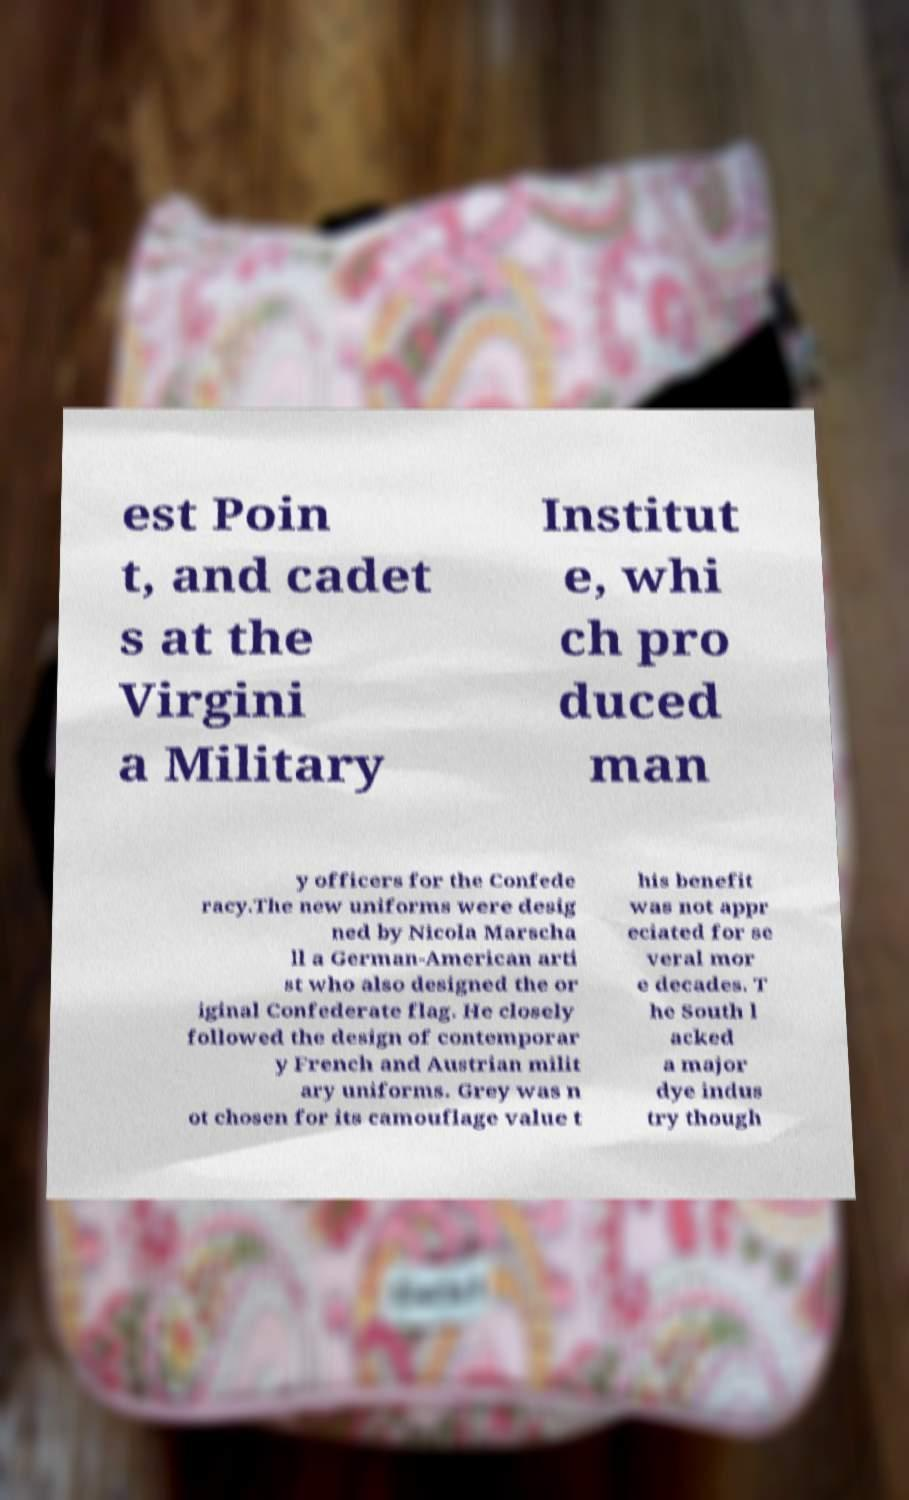Could you extract and type out the text from this image? est Poin t, and cadet s at the Virgini a Military Institut e, whi ch pro duced man y officers for the Confede racy.The new uniforms were desig ned by Nicola Marscha ll a German-American arti st who also designed the or iginal Confederate flag. He closely followed the design of contemporar y French and Austrian milit ary uniforms. Grey was n ot chosen for its camouflage value t his benefit was not appr eciated for se veral mor e decades. T he South l acked a major dye indus try though 